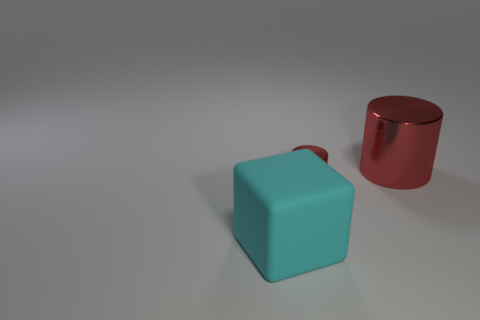Are there fewer gray objects than small red shiny things?
Your answer should be compact. Yes. Are the tiny red object and the big cyan thing made of the same material?
Your answer should be very brief. No. How many other objects are there of the same color as the big block?
Make the answer very short. 0. Are there more large red metal cylinders than shiny things?
Provide a succinct answer. No. There is a cyan rubber cube; does it have the same size as the red object to the right of the tiny red shiny cylinder?
Offer a very short reply. Yes. The big object in front of the large red shiny cylinder is what color?
Keep it short and to the point. Cyan. What number of blue things are metallic cylinders or large matte cubes?
Your response must be concise. 0. What color is the cube?
Offer a terse response. Cyan. Are there any other things that have the same material as the tiny red cylinder?
Provide a succinct answer. Yes. Is the number of big blocks that are in front of the matte block less than the number of cyan things to the right of the big red cylinder?
Make the answer very short. No. 